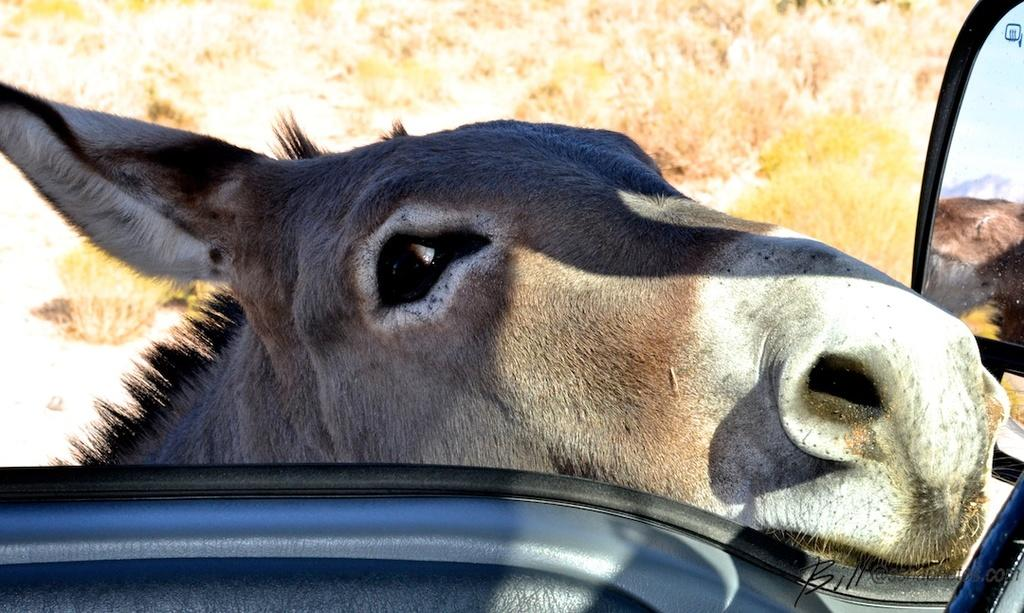What is depicted on the vehicle door in the image? There is a donkey face on the vehicle door. What safety feature is present on the vehicle? There is a side mirror on the vehicle. What can be seen in the background of the image? There are plants visible behind the vehicle. What type of credit card is visible in the image? There is no credit card present in the image. How many cars are visible in the image? The image only shows one vehicle, so there is only one car visible. 